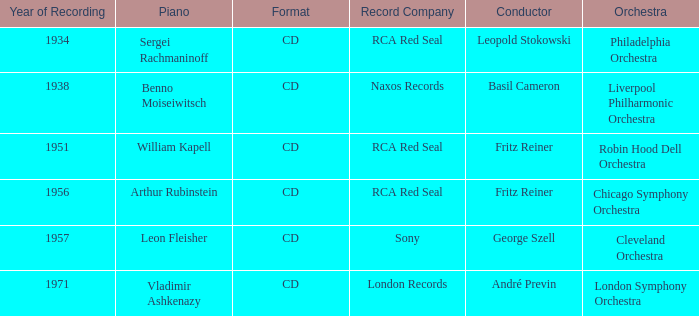Which orchestra has a recording year of 1951? Robin Hood Dell Orchestra. 